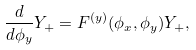<formula> <loc_0><loc_0><loc_500><loc_500>\frac { d } { d \phi _ { y } } Y _ { + } = F ^ { ( y ) } ( \phi _ { x } , \phi _ { y } ) Y _ { + } ,</formula> 